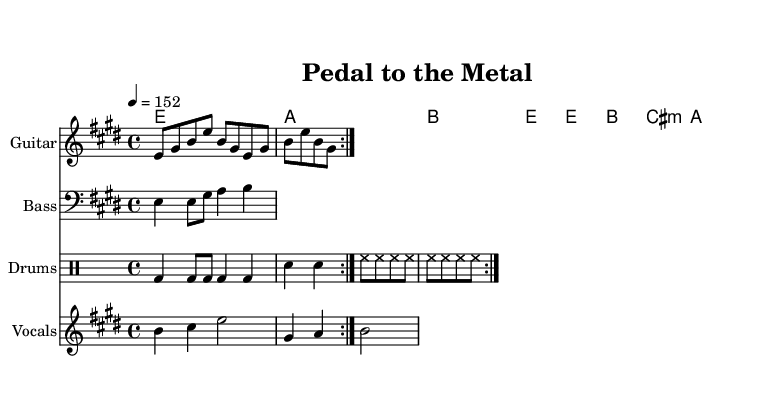What is the key signature of this music? The key signature is E major, which includes four sharps (F#, C#, G#, D#). This can be identified by looking at the beginning of the staff, where the sharps are indicated.
Answer: E major What is the time signature of this music? The time signature is 4/4, which can be seen indicated near the start of the piece. This means there are four beats in each measure, and each beat is a quarter note.
Answer: 4/4 What is the tempo marking for this piece? The tempo marking is 152, which is expressed as "4 = 152". This indicates that there are 152 beats per minute, and it helps set the speed for the performance.
Answer: 152 How many measures are repeated in the guitar riff? The guitar riff is indicated to repeat for two measures, as denoted by the "repeat volta 2" instruction in the music. This means that the section will be played twice before moving on.
Answer: 2 What instrument plays the melody? The melody is notated on the staff labeled "Vocals," indicating that this part is intended for singers. The notes and lyrics under this staff clearly align with vocal performance.
Answer: Vocals What is the overall genre of this piece? The music reflects a Country Rock genre, characterized by its driving rhythms and guitar riffs which emphasize themes of speed and racing, as evident in the instrumentation and style indicated.
Answer: Country Rock How many beats are in the drum pattern? The drum pattern is structured in a repetitive cycle of measures, with each measure containing four beats, consistent with the 4/4 time signature. Thus, for two measures, there are a total of eight beats.
Answer: 8 